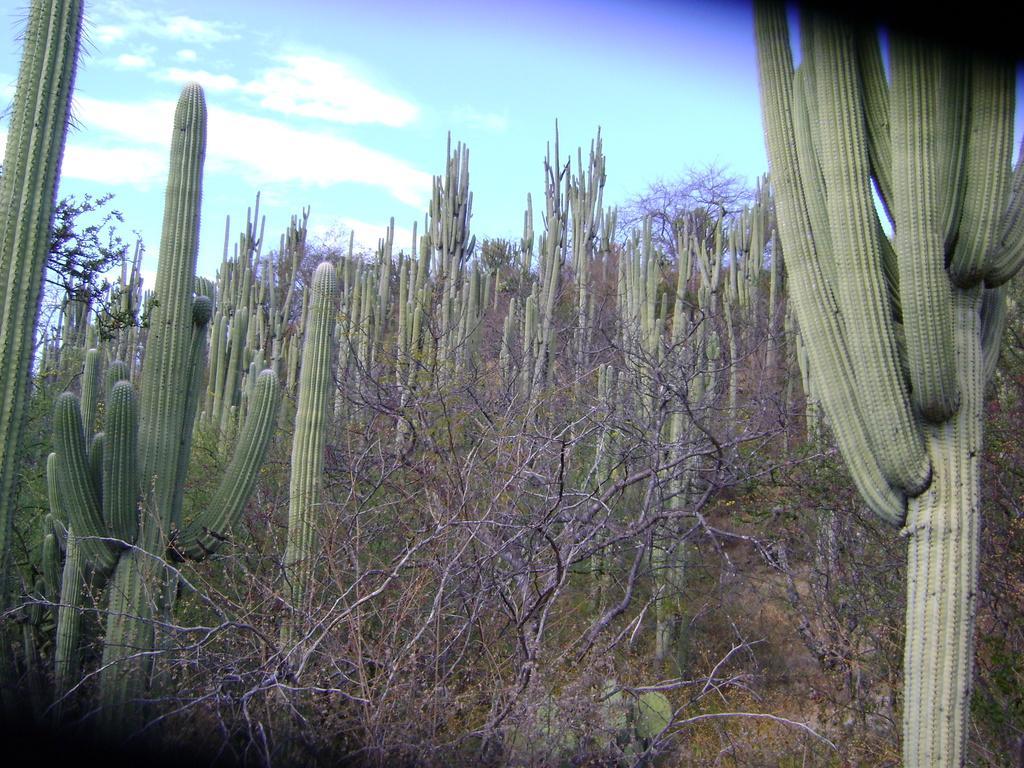Could you give a brief overview of what you see in this image? In this image I can see few dry trees and few cactus in green color. I can see the sky. 